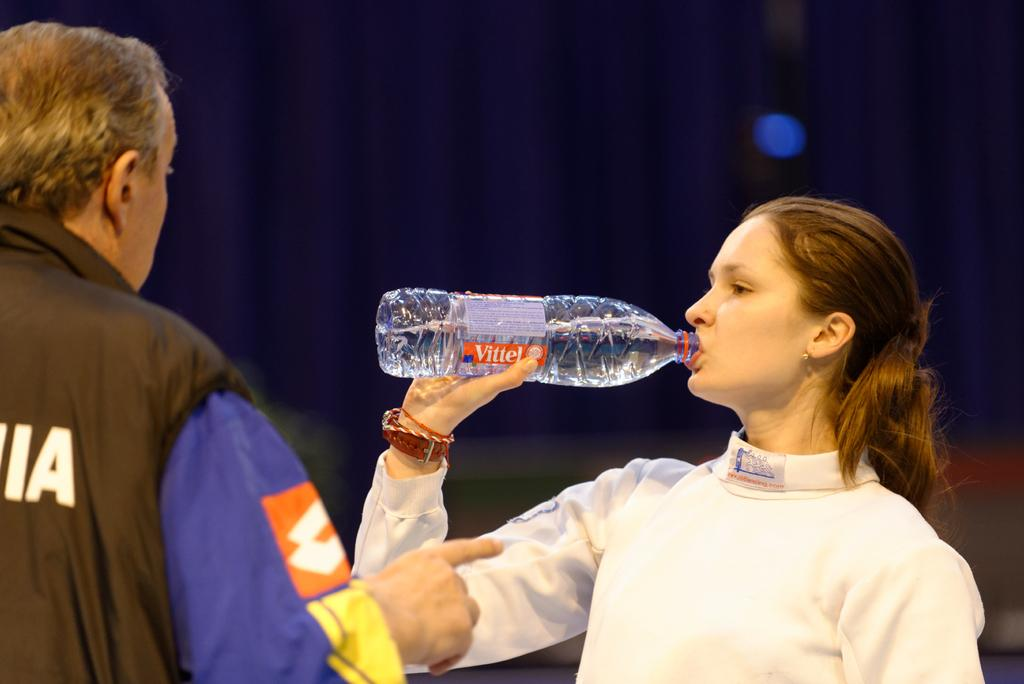<image>
Write a terse but informative summary of the picture. A woman drinks from a Vittel water bottle while talking to a man. 